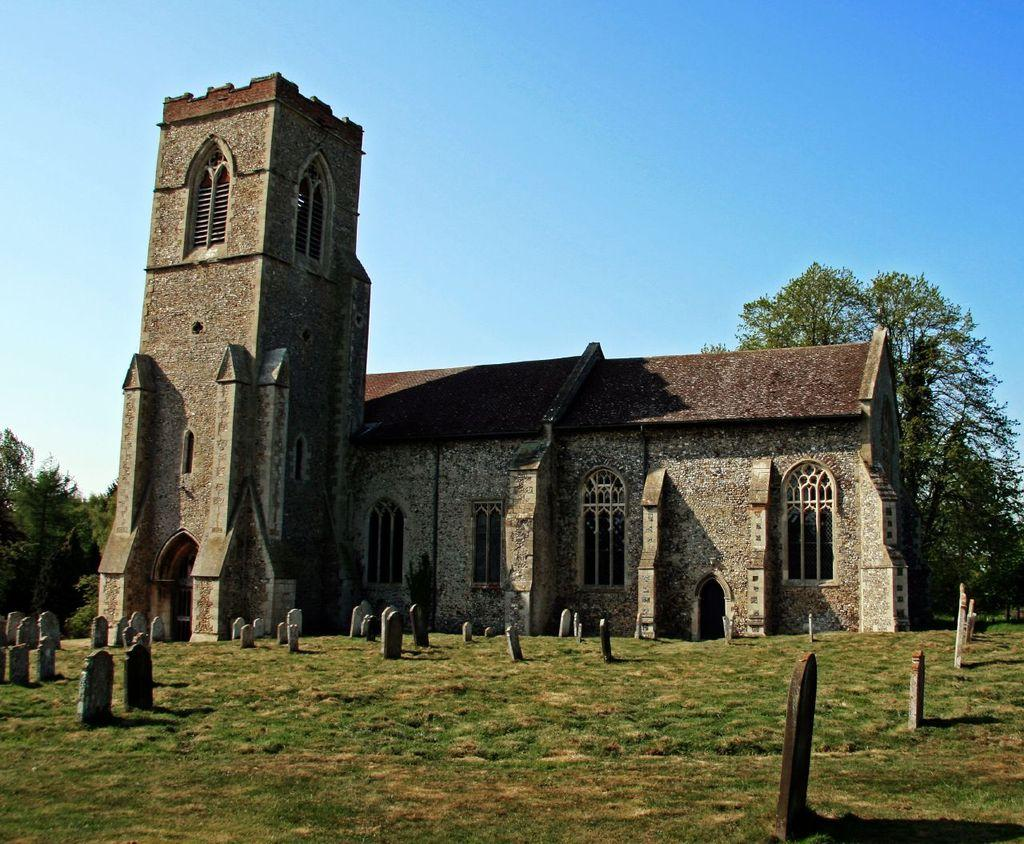What type of structure is visible in the image? There is a building in the image. What is located in front of the building? There are headstones placed on a greenery ground in front of the building. What can be seen in the background of the image? There are trees in the background of the image. What type of jam is being served at the train station in the image? There is no train station or jam present in the image. How many pies are visible on the windowsill of the building in the image? There is no mention of pies or a windowsill in the image. 